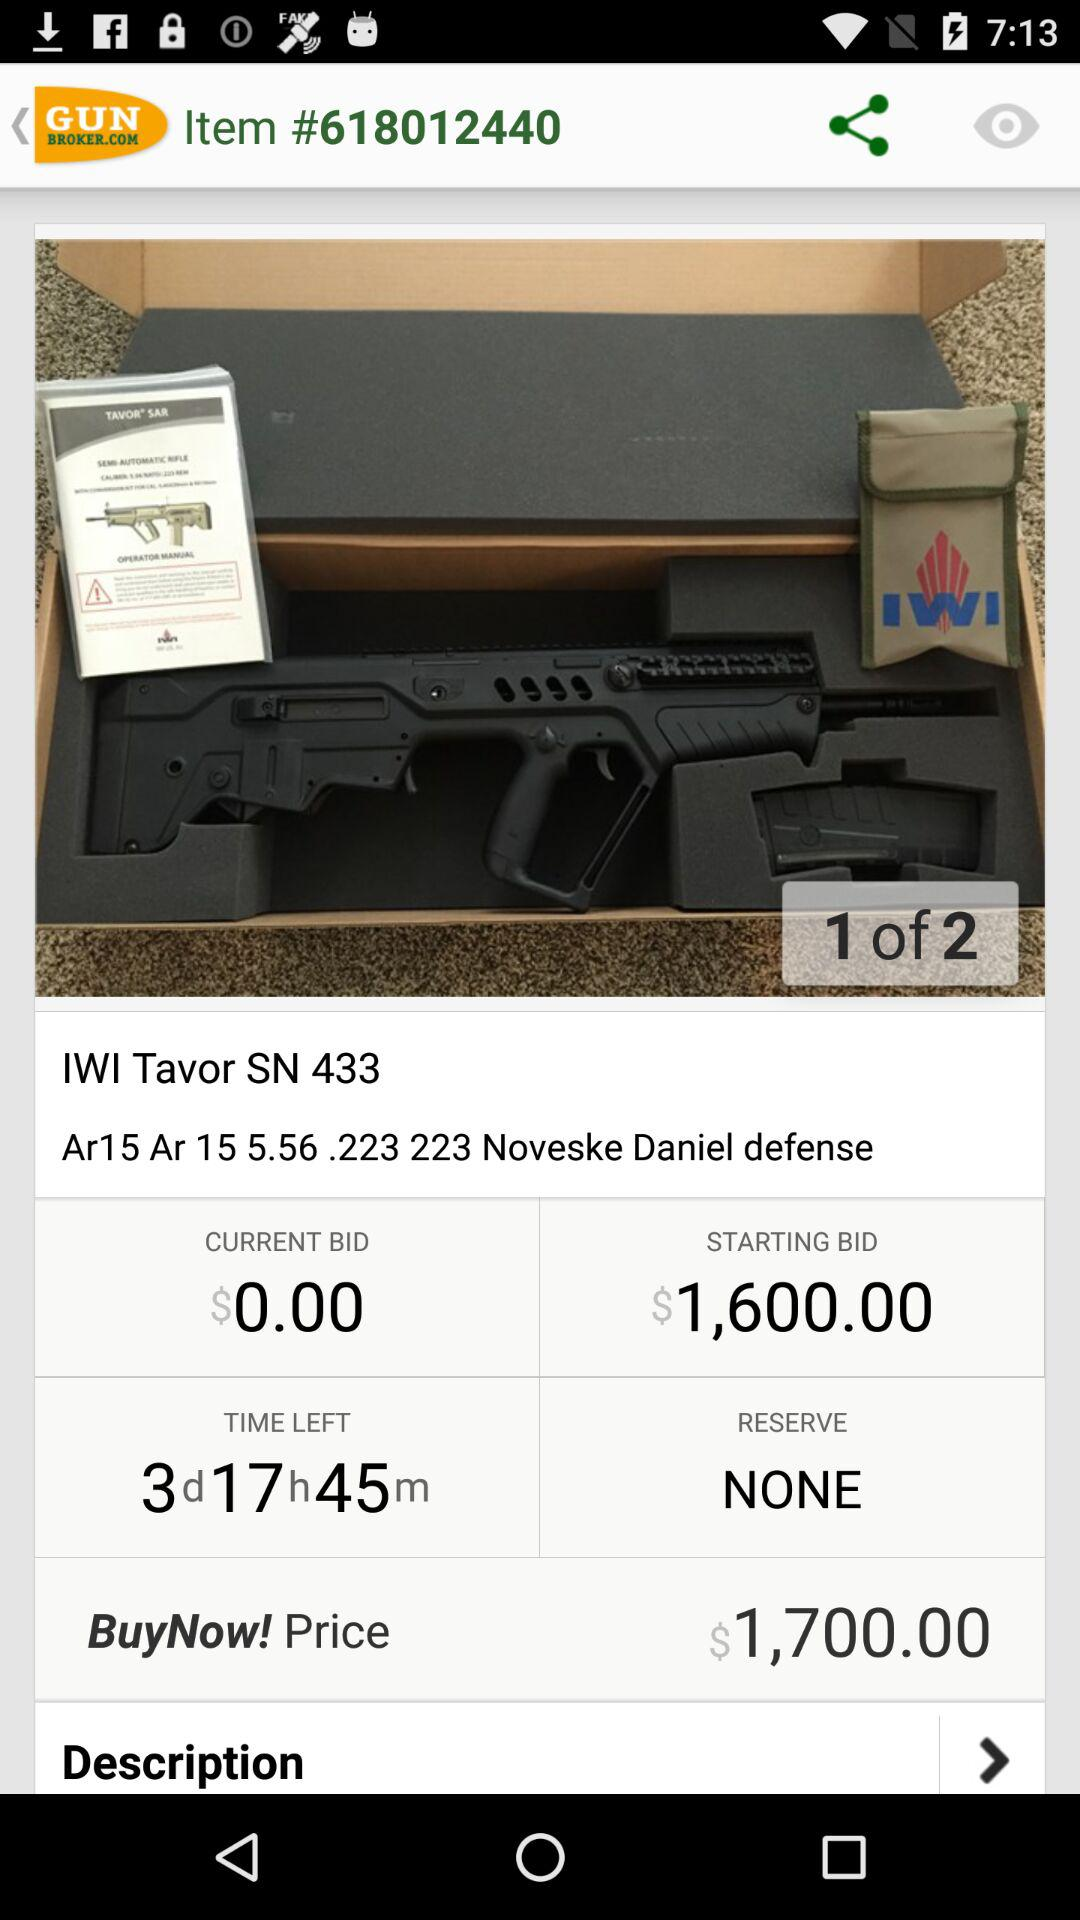How many pages in total are there? There are 2 pages. 